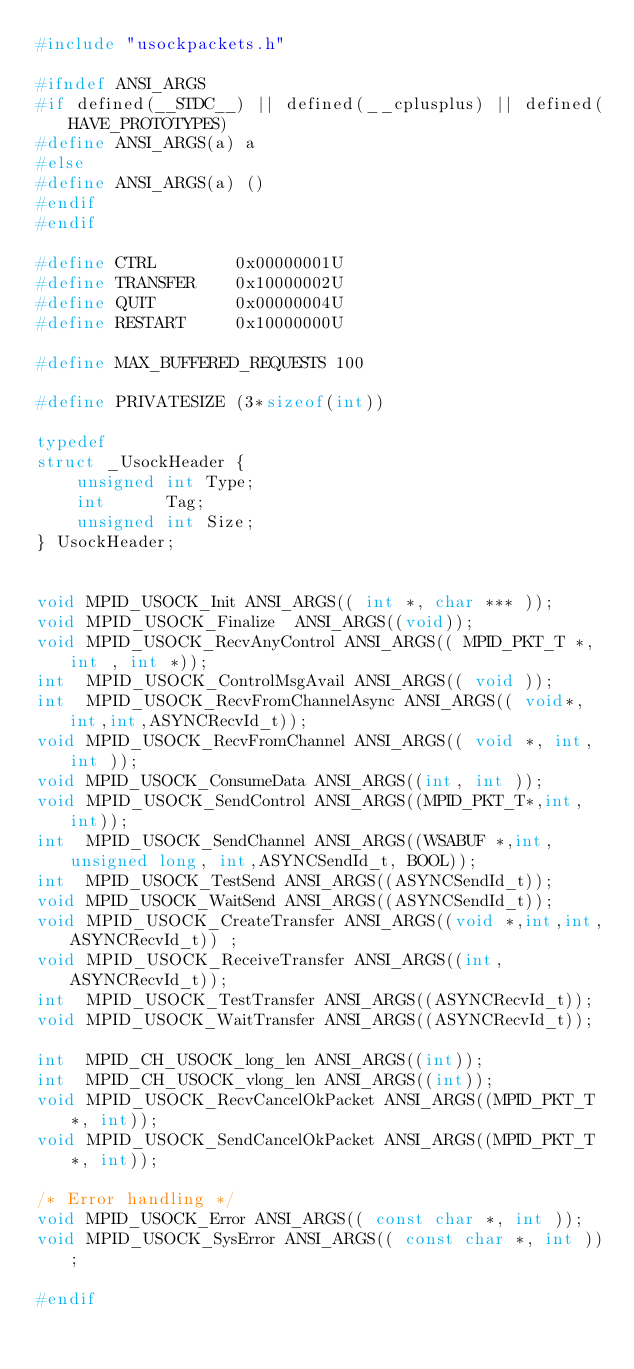Convert code to text. <code><loc_0><loc_0><loc_500><loc_500><_C_>#include "usockpackets.h"

#ifndef ANSI_ARGS
#if defined(__STDC__) || defined(__cplusplus) || defined(HAVE_PROTOTYPES)
#define ANSI_ARGS(a) a
#else
#define ANSI_ARGS(a) ()
#endif
#endif

#define CTRL		0x00000001U
#define TRANSFER	0x10000002U
#define QUIT		0x00000004U
#define RESTART		0x10000000U

#define MAX_BUFFERED_REQUESTS 100

#define PRIVATESIZE (3*sizeof(int))

typedef 
struct _UsockHeader {
	unsigned int Type;
	int	     Tag;
	unsigned int Size;
} UsockHeader;


void MPID_USOCK_Init ANSI_ARGS(( int *, char *** ));
void MPID_USOCK_Finalize  ANSI_ARGS((void));
void MPID_USOCK_RecvAnyControl ANSI_ARGS(( MPID_PKT_T *, int , int *));
int  MPID_USOCK_ControlMsgAvail ANSI_ARGS(( void ));
int  MPID_USOCK_RecvFromChannelAsync ANSI_ARGS(( void*,int,int,ASYNCRecvId_t));
void MPID_USOCK_RecvFromChannel ANSI_ARGS(( void *, int, int ));
void MPID_USOCK_ConsumeData ANSI_ARGS((int, int ));
void MPID_USOCK_SendControl ANSI_ARGS((MPID_PKT_T*,int,int));
int  MPID_USOCK_SendChannel ANSI_ARGS((WSABUF *,int, unsigned long, int,ASYNCSendId_t, BOOL));
int  MPID_USOCK_TestSend ANSI_ARGS((ASYNCSendId_t));
void MPID_USOCK_WaitSend ANSI_ARGS((ASYNCSendId_t));
void MPID_USOCK_CreateTransfer ANSI_ARGS((void *,int,int,ASYNCRecvId_t)) ;
void MPID_USOCK_ReceiveTransfer ANSI_ARGS((int,ASYNCRecvId_t));
int  MPID_USOCK_TestTransfer ANSI_ARGS((ASYNCRecvId_t));
void MPID_USOCK_WaitTransfer ANSI_ARGS((ASYNCRecvId_t));

int  MPID_CH_USOCK_long_len ANSI_ARGS((int));
int  MPID_CH_USOCK_vlong_len ANSI_ARGS((int));
void MPID_USOCK_RecvCancelOkPacket ANSI_ARGS((MPID_PKT_T*, int));
void MPID_USOCK_SendCancelOkPacket ANSI_ARGS((MPID_PKT_T*, int));

/* Error handling */
void MPID_USOCK_Error ANSI_ARGS(( const char *, int ));
void MPID_USOCK_SysError ANSI_ARGS(( const char *, int ));

#endif
</code> 